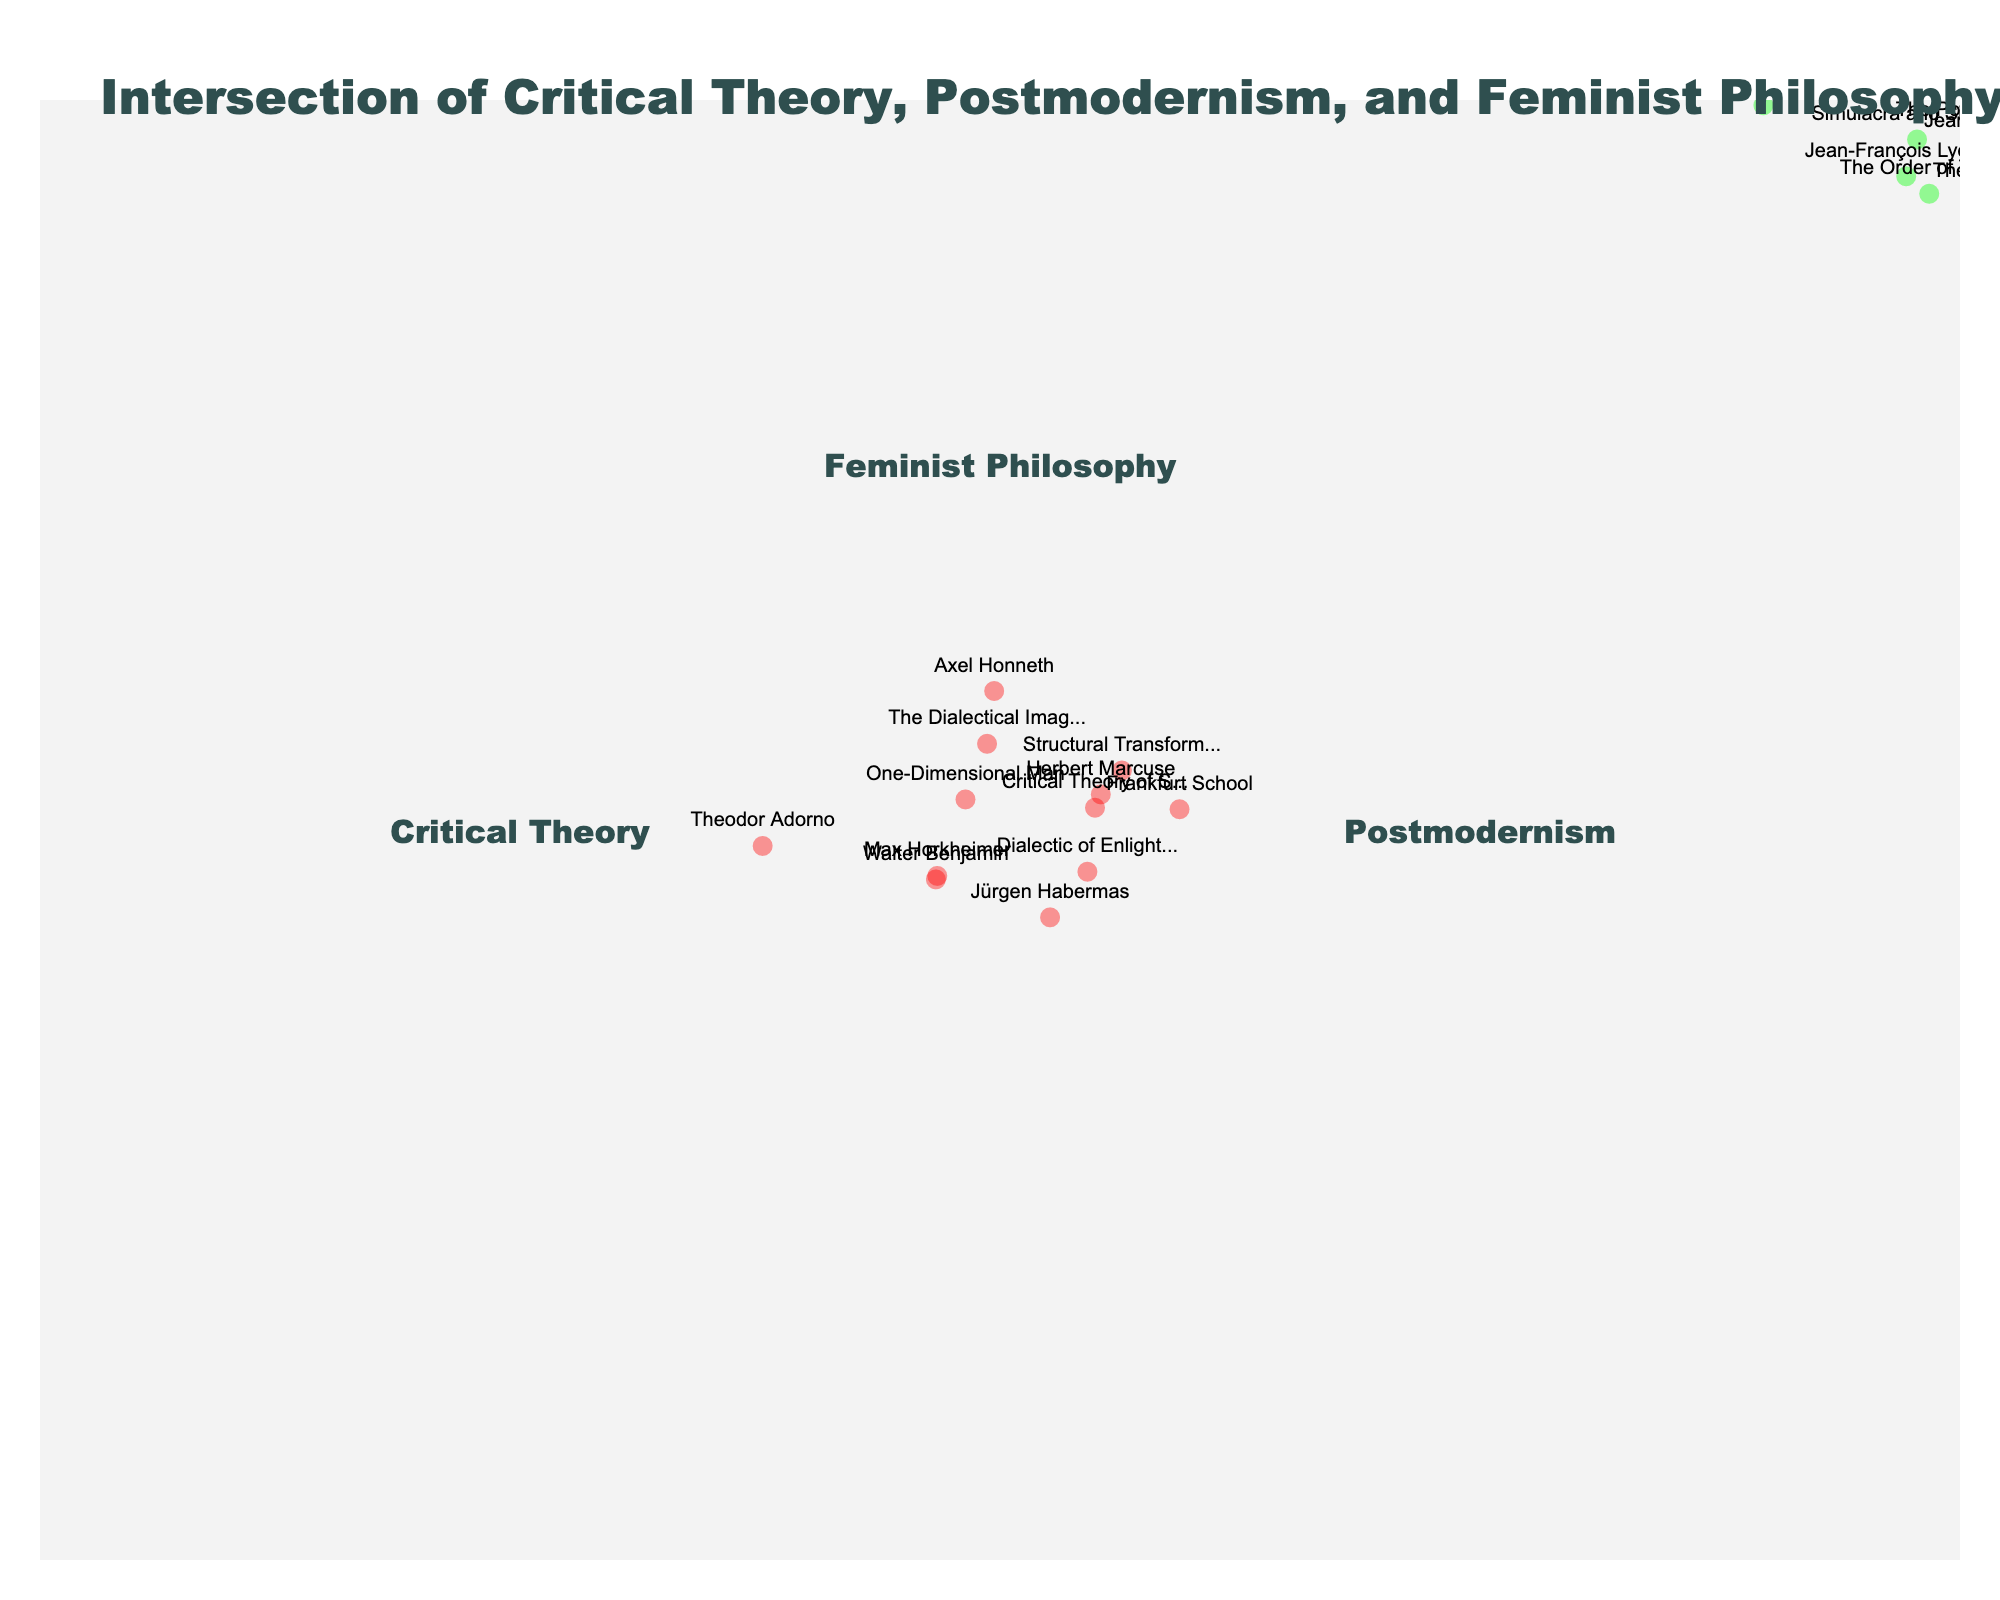What is the title of the Venn Diagram? The title is usually located at the top center of the figure.
Answer: Intersection of Critical Theory, Postmodernism, and Feminist Philosophy How many distinct sets are represented in the Venn Diagram? There are three main sets labeled in the figure, each representing a different intellectual movement.
Answer: Three Which set is associated with authors like Theodor Adorno and Walter Benjamin? Looking at the elements within the sets, Theodor Adorno and Walter Benjamin appear under the same set.
Answer: Critical Theory Is Donna Haraway associated with Critical Theory? We need to identify the set where Donna Haraway's name appears.
Answer: No Which intellectual movement covers "Deconstruction"? Find "Deconstruction" in the diagram and identify which set it belongs to.
Answer: Postmodernism How many elements are common to all three sets? To find shared elements, look at the intersection area where all three sets overlap.
Answer: None List the names associated with Postmodernism but not with Critical Theory and Feminist Philosophy. Find elements exclusive to the Postmodernism set that do not appear in the other two sets.
Answer: Jean Baudrillard, Michel Foucault, Fredric Jameson, The Postmodern Condition, Simulacra and Simulation, The Postmodern Turn Which text is associated with Feminist Philosophy and overlaps with Postmodernism but not Critical Theory? We need to find overlapping areas between Postmodernism and Feminist Philosophy excluding Critical Theory.
Answer: Sandra Harding If "The Dialectical Imagination" is removed from the Critical Theory set, how many elements remain? Count the items in the Critical Theory set and subtract one for "The Dialectical Imagination".
Answer: Six Is "Gender Trouble" part of the Feminist Philosophy set? Identify which set includes "Gender Trouble".
Answer: Yes 